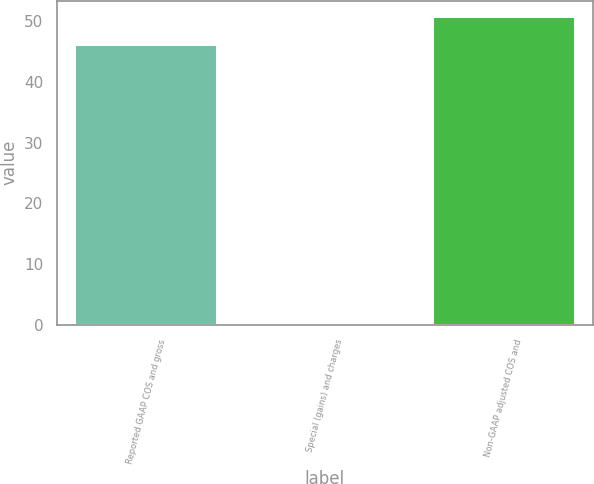Convert chart. <chart><loc_0><loc_0><loc_500><loc_500><bar_chart><fcel>Reported GAAP COS and gross<fcel>Special (gains) and charges<fcel>Non-GAAP adjusted COS and<nl><fcel>46.2<fcel>0.1<fcel>50.82<nl></chart> 